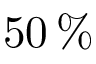Convert formula to latex. <formula><loc_0><loc_0><loc_500><loc_500>5 0 \, \%</formula> 